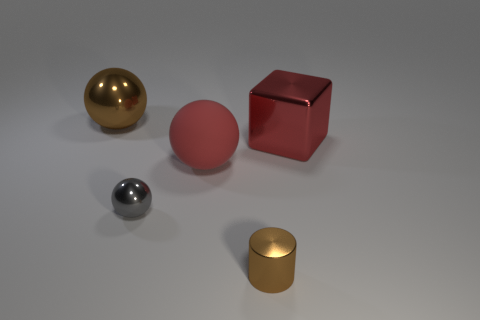Add 3 small cylinders. How many objects exist? 8 Subtract all red spheres. Subtract all red blocks. How many spheres are left? 2 Subtract all blocks. How many objects are left? 4 Add 2 big objects. How many big objects exist? 5 Subtract 0 brown blocks. How many objects are left? 5 Subtract all gray shiny things. Subtract all large red spheres. How many objects are left? 3 Add 2 small brown metallic things. How many small brown metallic things are left? 3 